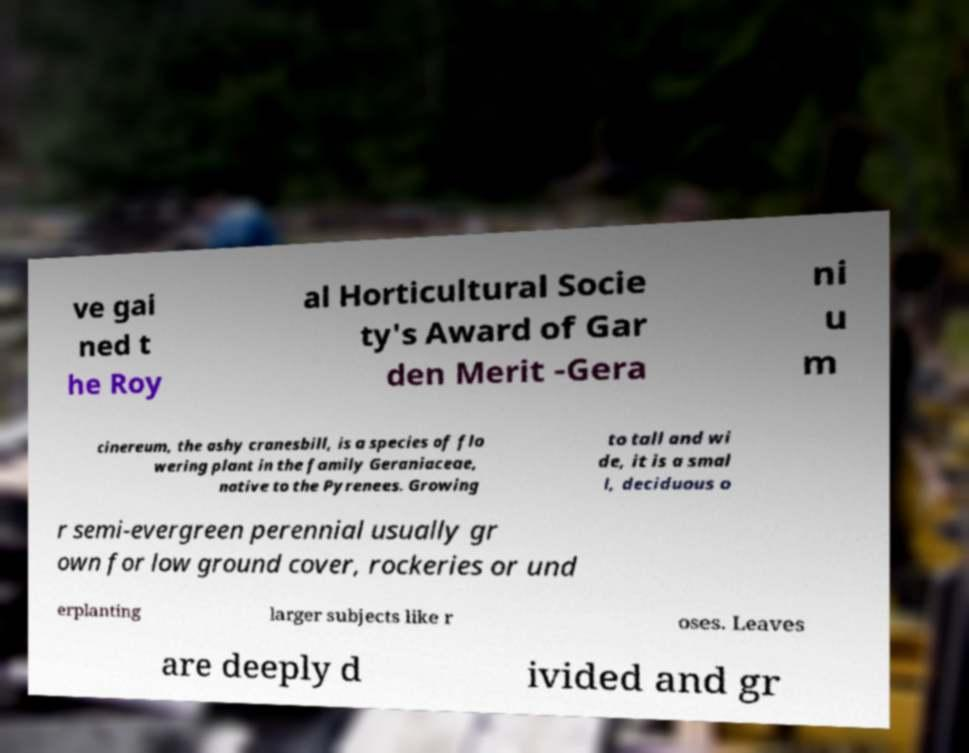Please identify and transcribe the text found in this image. ve gai ned t he Roy al Horticultural Socie ty's Award of Gar den Merit -Gera ni u m cinereum, the ashy cranesbill, is a species of flo wering plant in the family Geraniaceae, native to the Pyrenees. Growing to tall and wi de, it is a smal l, deciduous o r semi-evergreen perennial usually gr own for low ground cover, rockeries or und erplanting larger subjects like r oses. Leaves are deeply d ivided and gr 